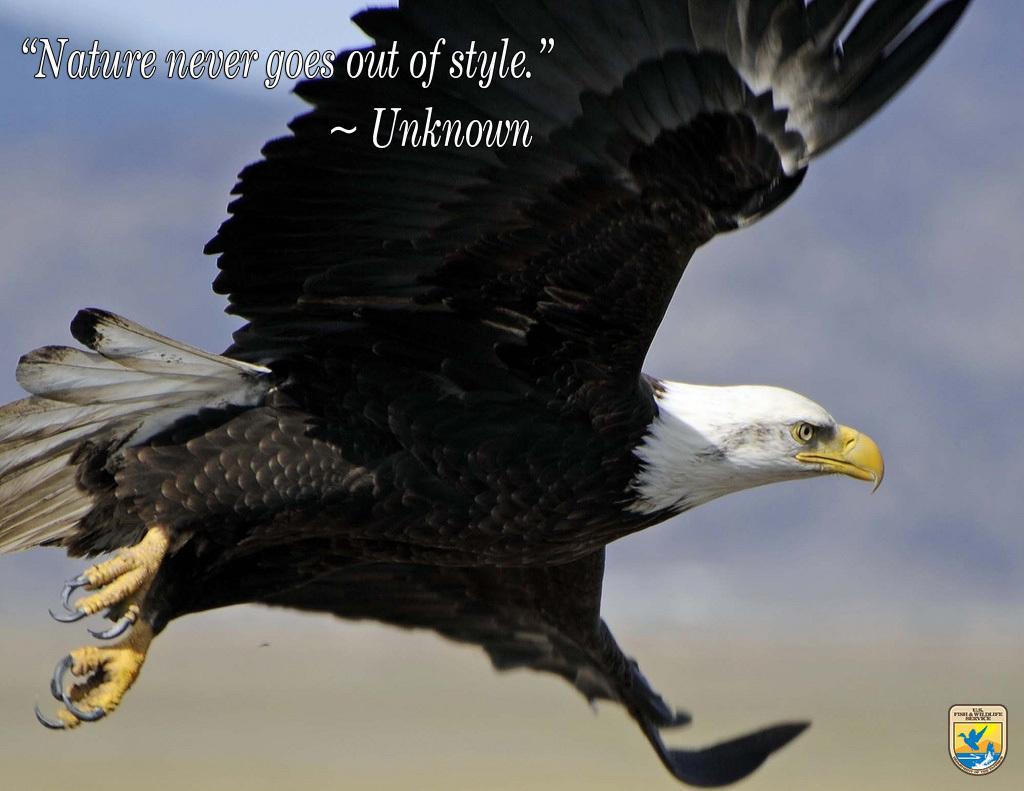How would you summarize this image in a sentence or two? In this image there is a bird in the air and there is some text written on the top of the image. 